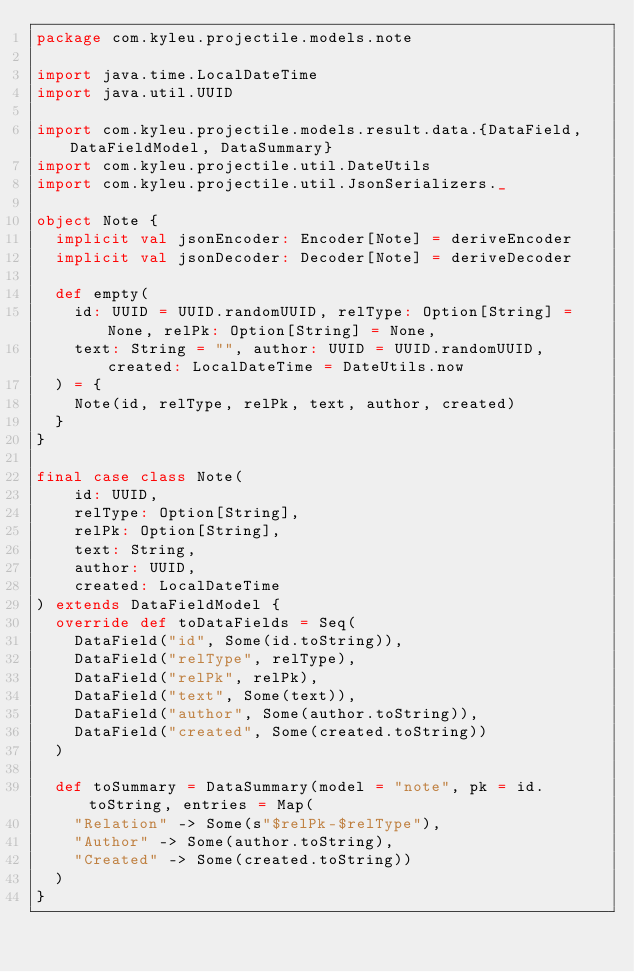<code> <loc_0><loc_0><loc_500><loc_500><_Scala_>package com.kyleu.projectile.models.note

import java.time.LocalDateTime
import java.util.UUID

import com.kyleu.projectile.models.result.data.{DataField, DataFieldModel, DataSummary}
import com.kyleu.projectile.util.DateUtils
import com.kyleu.projectile.util.JsonSerializers._

object Note {
  implicit val jsonEncoder: Encoder[Note] = deriveEncoder
  implicit val jsonDecoder: Decoder[Note] = deriveDecoder

  def empty(
    id: UUID = UUID.randomUUID, relType: Option[String] = None, relPk: Option[String] = None,
    text: String = "", author: UUID = UUID.randomUUID, created: LocalDateTime = DateUtils.now
  ) = {
    Note(id, relType, relPk, text, author, created)
  }
}

final case class Note(
    id: UUID,
    relType: Option[String],
    relPk: Option[String],
    text: String,
    author: UUID,
    created: LocalDateTime
) extends DataFieldModel {
  override def toDataFields = Seq(
    DataField("id", Some(id.toString)),
    DataField("relType", relType),
    DataField("relPk", relPk),
    DataField("text", Some(text)),
    DataField("author", Some(author.toString)),
    DataField("created", Some(created.toString))
  )

  def toSummary = DataSummary(model = "note", pk = id.toString, entries = Map(
    "Relation" -> Some(s"$relPk-$relType"),
    "Author" -> Some(author.toString),
    "Created" -> Some(created.toString))
  )
}
</code> 